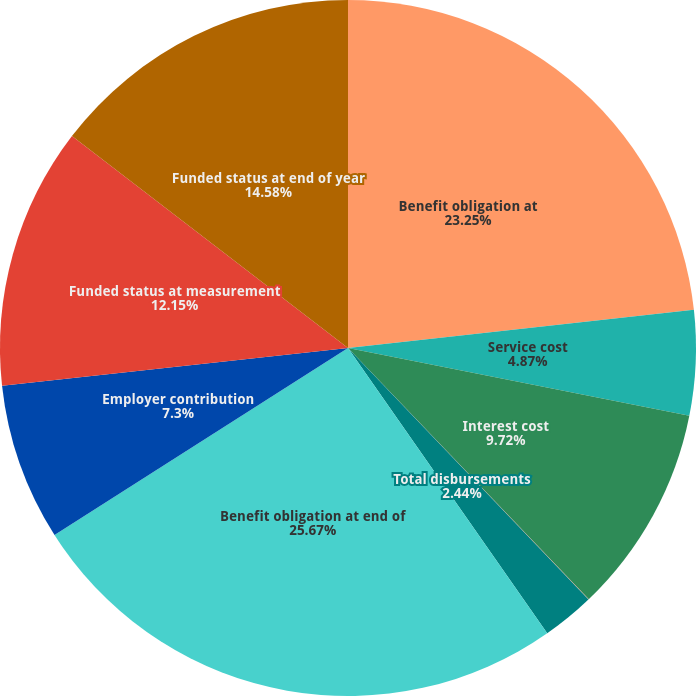Convert chart. <chart><loc_0><loc_0><loc_500><loc_500><pie_chart><fcel>Benefit obligation at<fcel>Service cost<fcel>Interest cost<fcel>Actuarial loss (gain)<fcel>Total disbursements<fcel>Benefit obligation at end of<fcel>Employer contribution<fcel>Funded status at measurement<fcel>Funded status at end of year<nl><fcel>23.25%<fcel>4.87%<fcel>9.72%<fcel>0.02%<fcel>2.44%<fcel>25.67%<fcel>7.3%<fcel>12.15%<fcel>14.58%<nl></chart> 